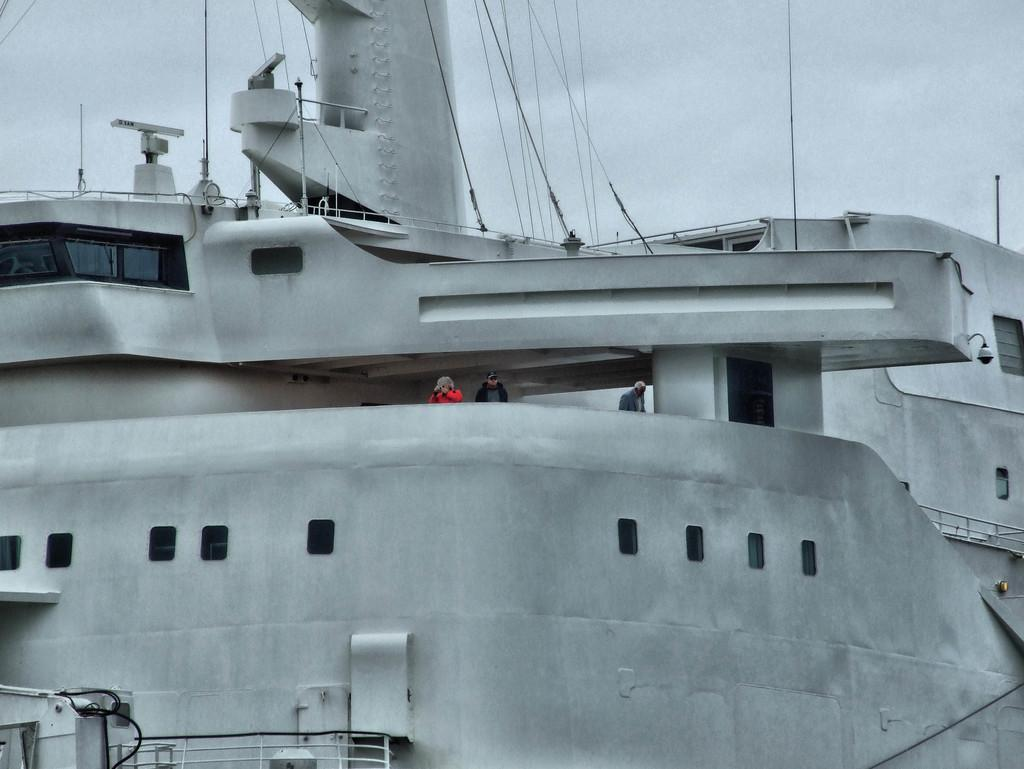What is the main subject of the image? The main subject of the image is a ship. Can you describe the color of the ship? The ship is white and black in color. How many people are on the ship? There are two persons in the ship. What are the people wearing? The persons are wearing red and black dresses. What can be seen in the background of the image? The sky is visible in the background of the image. What type of string is being used to hold the building together in the image? There is no building present in the image, and therefore no string being used to hold it together. 